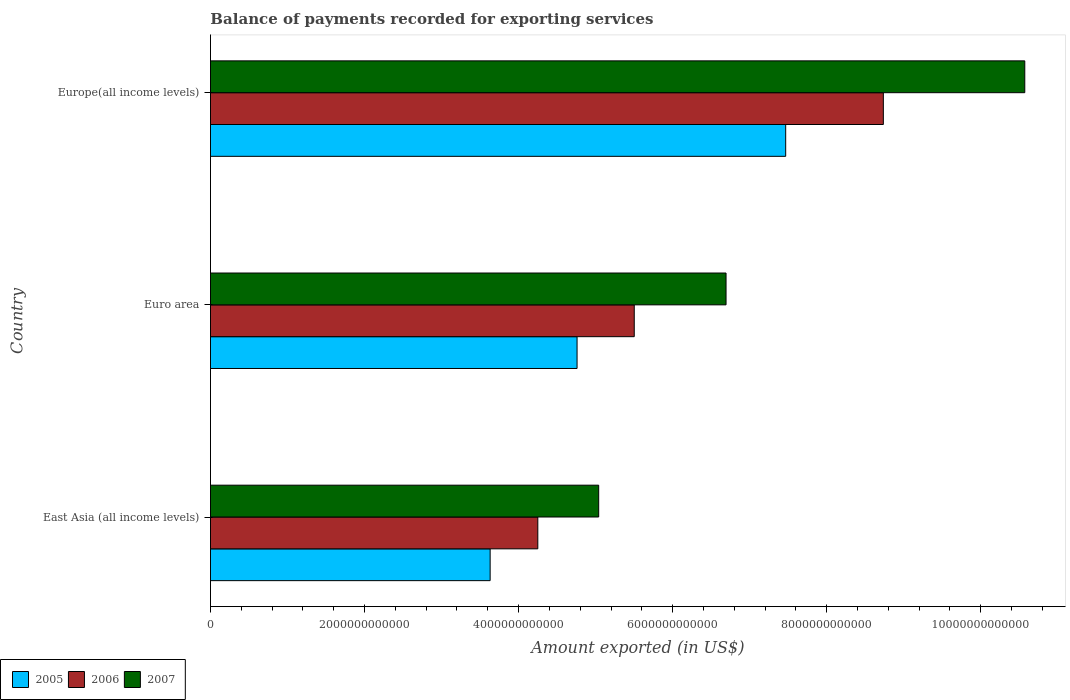How many groups of bars are there?
Your answer should be very brief. 3. How many bars are there on the 3rd tick from the top?
Provide a succinct answer. 3. How many bars are there on the 1st tick from the bottom?
Ensure brevity in your answer.  3. What is the label of the 3rd group of bars from the top?
Your answer should be very brief. East Asia (all income levels). In how many cases, is the number of bars for a given country not equal to the number of legend labels?
Provide a succinct answer. 0. What is the amount exported in 2005 in East Asia (all income levels)?
Your answer should be very brief. 3.63e+12. Across all countries, what is the maximum amount exported in 2005?
Your answer should be compact. 7.47e+12. Across all countries, what is the minimum amount exported in 2007?
Offer a terse response. 5.04e+12. In which country was the amount exported in 2005 maximum?
Your answer should be very brief. Europe(all income levels). In which country was the amount exported in 2006 minimum?
Your answer should be compact. East Asia (all income levels). What is the total amount exported in 2005 in the graph?
Offer a terse response. 1.59e+13. What is the difference between the amount exported in 2007 in Euro area and that in Europe(all income levels)?
Offer a very short reply. -3.88e+12. What is the difference between the amount exported in 2006 in East Asia (all income levels) and the amount exported in 2005 in Europe(all income levels)?
Ensure brevity in your answer.  -3.22e+12. What is the average amount exported in 2005 per country?
Keep it short and to the point. 5.29e+12. What is the difference between the amount exported in 2007 and amount exported in 2006 in Europe(all income levels)?
Provide a succinct answer. 1.84e+12. What is the ratio of the amount exported in 2007 in East Asia (all income levels) to that in Euro area?
Keep it short and to the point. 0.75. Is the difference between the amount exported in 2007 in Euro area and Europe(all income levels) greater than the difference between the amount exported in 2006 in Euro area and Europe(all income levels)?
Offer a very short reply. No. What is the difference between the highest and the second highest amount exported in 2005?
Your response must be concise. 2.71e+12. What is the difference between the highest and the lowest amount exported in 2007?
Make the answer very short. 5.53e+12. Is the sum of the amount exported in 2005 in East Asia (all income levels) and Euro area greater than the maximum amount exported in 2007 across all countries?
Give a very brief answer. No. Are all the bars in the graph horizontal?
Offer a very short reply. Yes. How many countries are there in the graph?
Your response must be concise. 3. What is the difference between two consecutive major ticks on the X-axis?
Provide a succinct answer. 2.00e+12. Does the graph contain any zero values?
Provide a short and direct response. No. Where does the legend appear in the graph?
Ensure brevity in your answer.  Bottom left. How many legend labels are there?
Your answer should be very brief. 3. What is the title of the graph?
Make the answer very short. Balance of payments recorded for exporting services. Does "1982" appear as one of the legend labels in the graph?
Make the answer very short. No. What is the label or title of the X-axis?
Make the answer very short. Amount exported (in US$). What is the label or title of the Y-axis?
Your response must be concise. Country. What is the Amount exported (in US$) in 2005 in East Asia (all income levels)?
Provide a short and direct response. 3.63e+12. What is the Amount exported (in US$) of 2006 in East Asia (all income levels)?
Ensure brevity in your answer.  4.25e+12. What is the Amount exported (in US$) in 2007 in East Asia (all income levels)?
Provide a short and direct response. 5.04e+12. What is the Amount exported (in US$) in 2005 in Euro area?
Give a very brief answer. 4.76e+12. What is the Amount exported (in US$) of 2006 in Euro area?
Give a very brief answer. 5.50e+12. What is the Amount exported (in US$) in 2007 in Euro area?
Your answer should be compact. 6.69e+12. What is the Amount exported (in US$) in 2005 in Europe(all income levels)?
Give a very brief answer. 7.47e+12. What is the Amount exported (in US$) in 2006 in Europe(all income levels)?
Provide a succinct answer. 8.74e+12. What is the Amount exported (in US$) in 2007 in Europe(all income levels)?
Offer a terse response. 1.06e+13. Across all countries, what is the maximum Amount exported (in US$) in 2005?
Provide a short and direct response. 7.47e+12. Across all countries, what is the maximum Amount exported (in US$) of 2006?
Give a very brief answer. 8.74e+12. Across all countries, what is the maximum Amount exported (in US$) in 2007?
Your response must be concise. 1.06e+13. Across all countries, what is the minimum Amount exported (in US$) in 2005?
Give a very brief answer. 3.63e+12. Across all countries, what is the minimum Amount exported (in US$) in 2006?
Give a very brief answer. 4.25e+12. Across all countries, what is the minimum Amount exported (in US$) in 2007?
Your response must be concise. 5.04e+12. What is the total Amount exported (in US$) of 2005 in the graph?
Provide a succinct answer. 1.59e+13. What is the total Amount exported (in US$) in 2006 in the graph?
Offer a very short reply. 1.85e+13. What is the total Amount exported (in US$) in 2007 in the graph?
Provide a succinct answer. 2.23e+13. What is the difference between the Amount exported (in US$) of 2005 in East Asia (all income levels) and that in Euro area?
Offer a terse response. -1.13e+12. What is the difference between the Amount exported (in US$) in 2006 in East Asia (all income levels) and that in Euro area?
Provide a succinct answer. -1.25e+12. What is the difference between the Amount exported (in US$) of 2007 in East Asia (all income levels) and that in Euro area?
Provide a succinct answer. -1.65e+12. What is the difference between the Amount exported (in US$) of 2005 in East Asia (all income levels) and that in Europe(all income levels)?
Offer a terse response. -3.84e+12. What is the difference between the Amount exported (in US$) of 2006 in East Asia (all income levels) and that in Europe(all income levels)?
Your answer should be very brief. -4.49e+12. What is the difference between the Amount exported (in US$) in 2007 in East Asia (all income levels) and that in Europe(all income levels)?
Your answer should be compact. -5.53e+12. What is the difference between the Amount exported (in US$) in 2005 in Euro area and that in Europe(all income levels)?
Ensure brevity in your answer.  -2.71e+12. What is the difference between the Amount exported (in US$) in 2006 in Euro area and that in Europe(all income levels)?
Provide a short and direct response. -3.23e+12. What is the difference between the Amount exported (in US$) in 2007 in Euro area and that in Europe(all income levels)?
Provide a succinct answer. -3.88e+12. What is the difference between the Amount exported (in US$) in 2005 in East Asia (all income levels) and the Amount exported (in US$) in 2006 in Euro area?
Your answer should be very brief. -1.87e+12. What is the difference between the Amount exported (in US$) in 2005 in East Asia (all income levels) and the Amount exported (in US$) in 2007 in Euro area?
Your answer should be very brief. -3.06e+12. What is the difference between the Amount exported (in US$) in 2006 in East Asia (all income levels) and the Amount exported (in US$) in 2007 in Euro area?
Your answer should be very brief. -2.44e+12. What is the difference between the Amount exported (in US$) of 2005 in East Asia (all income levels) and the Amount exported (in US$) of 2006 in Europe(all income levels)?
Provide a short and direct response. -5.10e+12. What is the difference between the Amount exported (in US$) in 2005 in East Asia (all income levels) and the Amount exported (in US$) in 2007 in Europe(all income levels)?
Offer a terse response. -6.94e+12. What is the difference between the Amount exported (in US$) of 2006 in East Asia (all income levels) and the Amount exported (in US$) of 2007 in Europe(all income levels)?
Your answer should be compact. -6.32e+12. What is the difference between the Amount exported (in US$) in 2005 in Euro area and the Amount exported (in US$) in 2006 in Europe(all income levels)?
Provide a succinct answer. -3.98e+12. What is the difference between the Amount exported (in US$) of 2005 in Euro area and the Amount exported (in US$) of 2007 in Europe(all income levels)?
Provide a short and direct response. -5.81e+12. What is the difference between the Amount exported (in US$) of 2006 in Euro area and the Amount exported (in US$) of 2007 in Europe(all income levels)?
Your response must be concise. -5.07e+12. What is the average Amount exported (in US$) in 2005 per country?
Provide a succinct answer. 5.29e+12. What is the average Amount exported (in US$) of 2006 per country?
Your response must be concise. 6.16e+12. What is the average Amount exported (in US$) in 2007 per country?
Offer a terse response. 7.43e+12. What is the difference between the Amount exported (in US$) of 2005 and Amount exported (in US$) of 2006 in East Asia (all income levels)?
Keep it short and to the point. -6.19e+11. What is the difference between the Amount exported (in US$) in 2005 and Amount exported (in US$) in 2007 in East Asia (all income levels)?
Offer a very short reply. -1.41e+12. What is the difference between the Amount exported (in US$) of 2006 and Amount exported (in US$) of 2007 in East Asia (all income levels)?
Make the answer very short. -7.90e+11. What is the difference between the Amount exported (in US$) in 2005 and Amount exported (in US$) in 2006 in Euro area?
Your answer should be compact. -7.42e+11. What is the difference between the Amount exported (in US$) of 2005 and Amount exported (in US$) of 2007 in Euro area?
Provide a short and direct response. -1.93e+12. What is the difference between the Amount exported (in US$) in 2006 and Amount exported (in US$) in 2007 in Euro area?
Make the answer very short. -1.19e+12. What is the difference between the Amount exported (in US$) of 2005 and Amount exported (in US$) of 2006 in Europe(all income levels)?
Your response must be concise. -1.27e+12. What is the difference between the Amount exported (in US$) of 2005 and Amount exported (in US$) of 2007 in Europe(all income levels)?
Keep it short and to the point. -3.10e+12. What is the difference between the Amount exported (in US$) of 2006 and Amount exported (in US$) of 2007 in Europe(all income levels)?
Your response must be concise. -1.84e+12. What is the ratio of the Amount exported (in US$) in 2005 in East Asia (all income levels) to that in Euro area?
Keep it short and to the point. 0.76. What is the ratio of the Amount exported (in US$) in 2006 in East Asia (all income levels) to that in Euro area?
Provide a succinct answer. 0.77. What is the ratio of the Amount exported (in US$) in 2007 in East Asia (all income levels) to that in Euro area?
Provide a short and direct response. 0.75. What is the ratio of the Amount exported (in US$) in 2005 in East Asia (all income levels) to that in Europe(all income levels)?
Ensure brevity in your answer.  0.49. What is the ratio of the Amount exported (in US$) in 2006 in East Asia (all income levels) to that in Europe(all income levels)?
Keep it short and to the point. 0.49. What is the ratio of the Amount exported (in US$) in 2007 in East Asia (all income levels) to that in Europe(all income levels)?
Offer a very short reply. 0.48. What is the ratio of the Amount exported (in US$) of 2005 in Euro area to that in Europe(all income levels)?
Your response must be concise. 0.64. What is the ratio of the Amount exported (in US$) in 2006 in Euro area to that in Europe(all income levels)?
Make the answer very short. 0.63. What is the ratio of the Amount exported (in US$) in 2007 in Euro area to that in Europe(all income levels)?
Your response must be concise. 0.63. What is the difference between the highest and the second highest Amount exported (in US$) of 2005?
Offer a terse response. 2.71e+12. What is the difference between the highest and the second highest Amount exported (in US$) in 2006?
Keep it short and to the point. 3.23e+12. What is the difference between the highest and the second highest Amount exported (in US$) of 2007?
Provide a short and direct response. 3.88e+12. What is the difference between the highest and the lowest Amount exported (in US$) in 2005?
Make the answer very short. 3.84e+12. What is the difference between the highest and the lowest Amount exported (in US$) of 2006?
Give a very brief answer. 4.49e+12. What is the difference between the highest and the lowest Amount exported (in US$) in 2007?
Ensure brevity in your answer.  5.53e+12. 